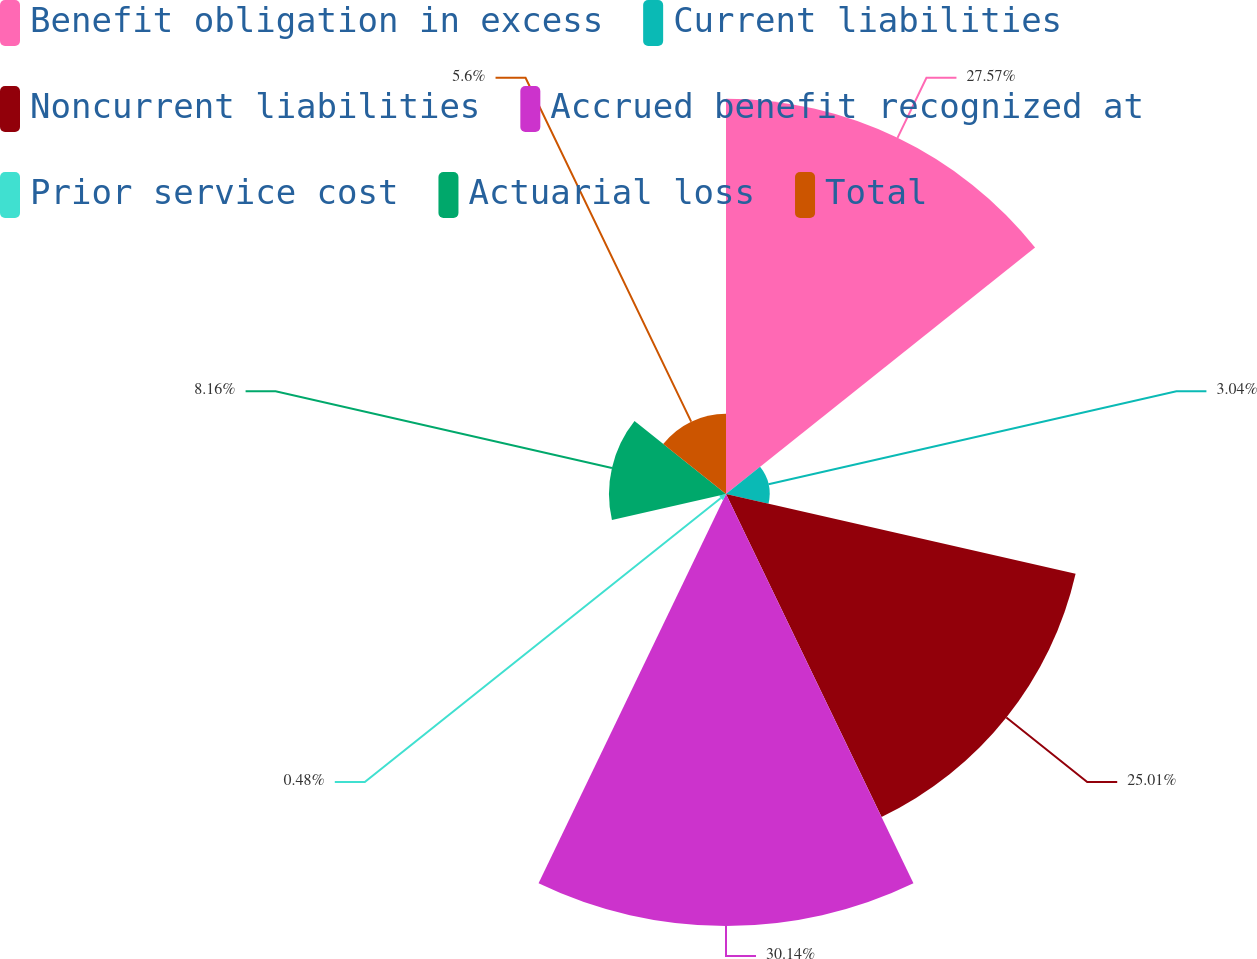<chart> <loc_0><loc_0><loc_500><loc_500><pie_chart><fcel>Benefit obligation in excess<fcel>Current liabilities<fcel>Noncurrent liabilities<fcel>Accrued benefit recognized at<fcel>Prior service cost<fcel>Actuarial loss<fcel>Total<nl><fcel>27.57%<fcel>3.04%<fcel>25.01%<fcel>30.13%<fcel>0.48%<fcel>8.16%<fcel>5.6%<nl></chart> 